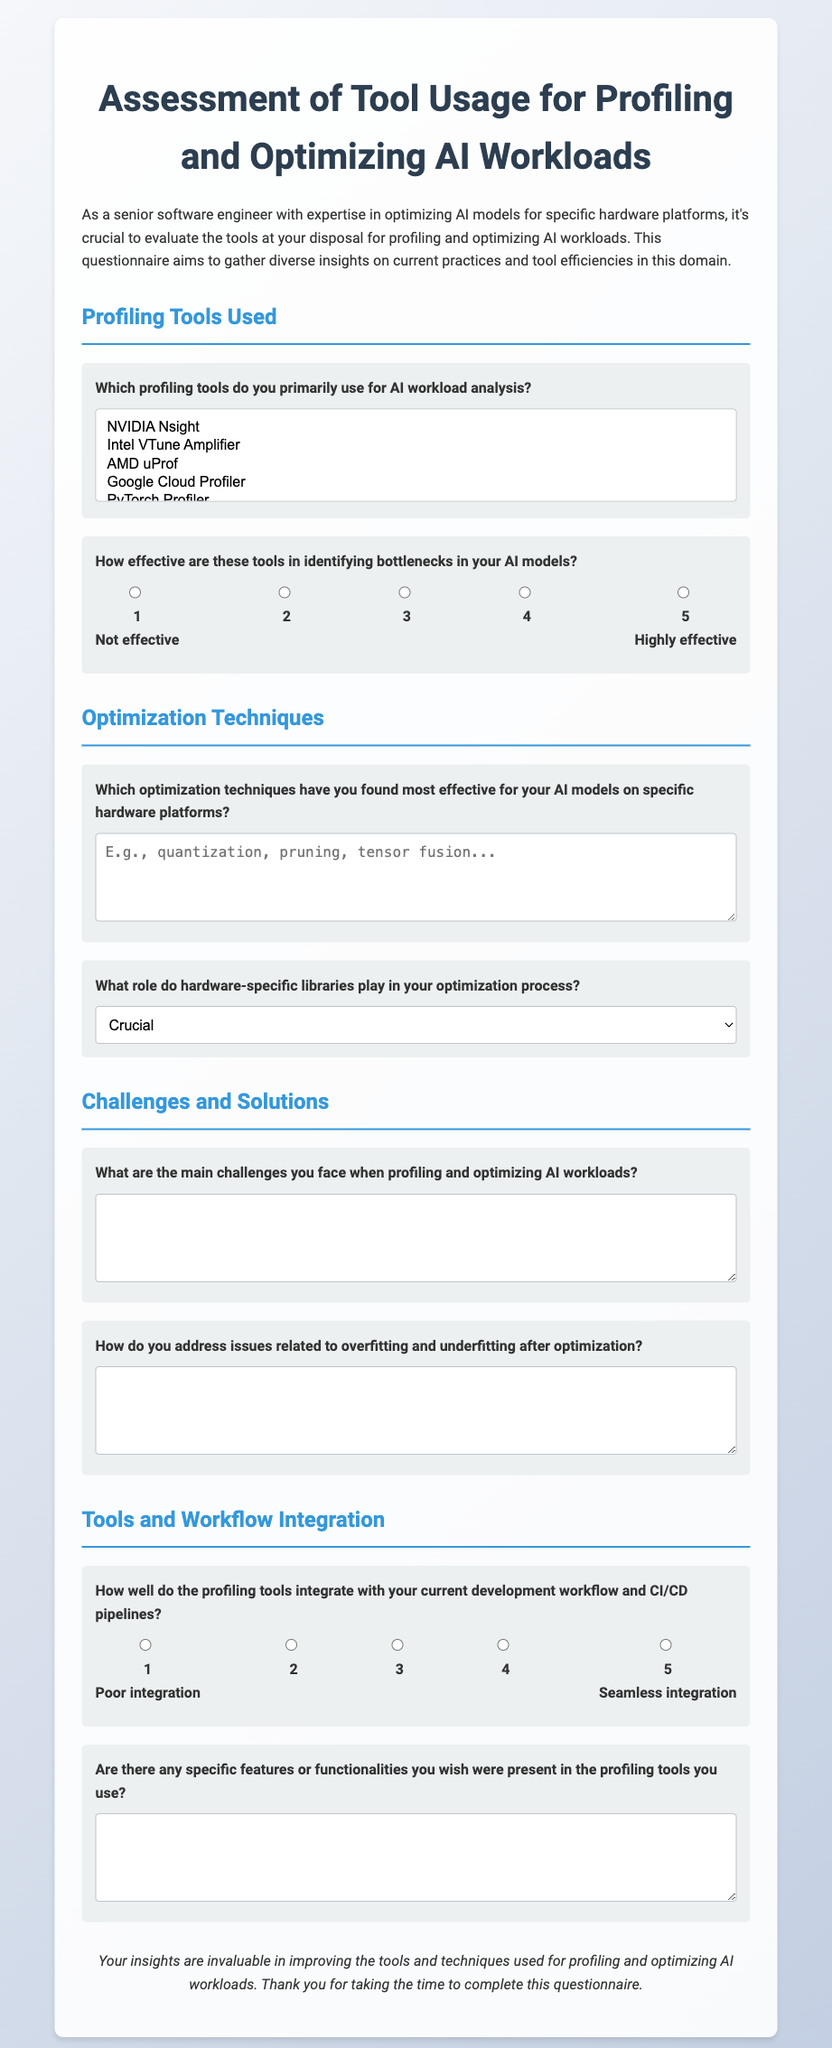Which profiling tools are listed? The document contains a selection of profiling tools that users can choose from, including NVIDIA Nsight, Intel VTune Amplifier, AMD uProf, Google Cloud Profiler, PyTorch Profiler, and TensorFlow Profiler.
Answer: NVIDIA Nsight, Intel VTune Amplifier, AMD uProf, Google Cloud Profiler, PyTorch Profiler, TensorFlow Profiler What is the effectiveness rating scale range? The document shows a 5-point scale for effectiveness, ranging from 1 to 5, where 1 represents not effective and 5 represents highly effective.
Answer: 1 to 5 What techniques can be described in the optimization section? The questionnaire invites users to describe optimization techniques they found effective, with examples like quantization, pruning, and tensor fusion mentioned.
Answer: quantization, pruning, tensor fusion How do hardware-specific libraries rank in importance during optimization? The document provides options to gauge the role of hardware-specific libraries, including crucial, important, moderate, minimal, and not used.
Answer: Crucial What does the conclusion emphasize? The conclusion of the document highlights the value of participant insights in improving tools and techniques for profiling and optimizing AI workloads.
Answer: Improving tools and techniques 